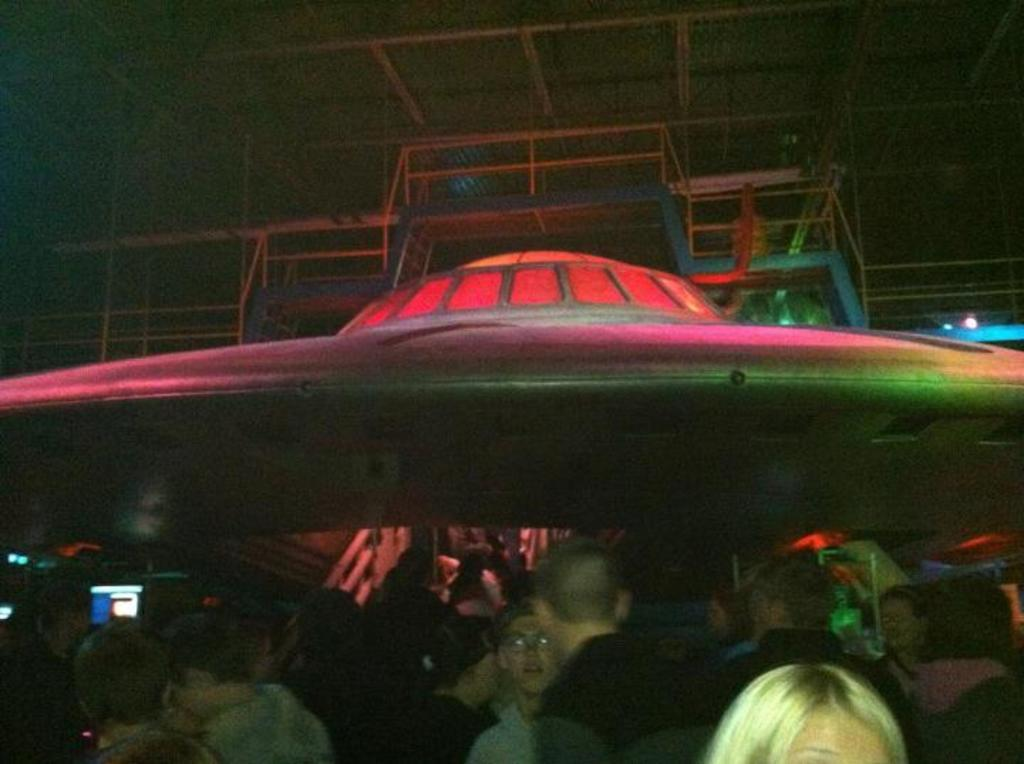What is happening in the image? There are people standing in the image. What can be seen in the background of the image? There are lights in the background of the image. What is the unusual element depicted in the image? There is a depiction of a UFO in the image. What type of pancake is being flipped by the girl in the image? There is no girl or pancake present in the image; it features people standing and a depiction of a UFO. 